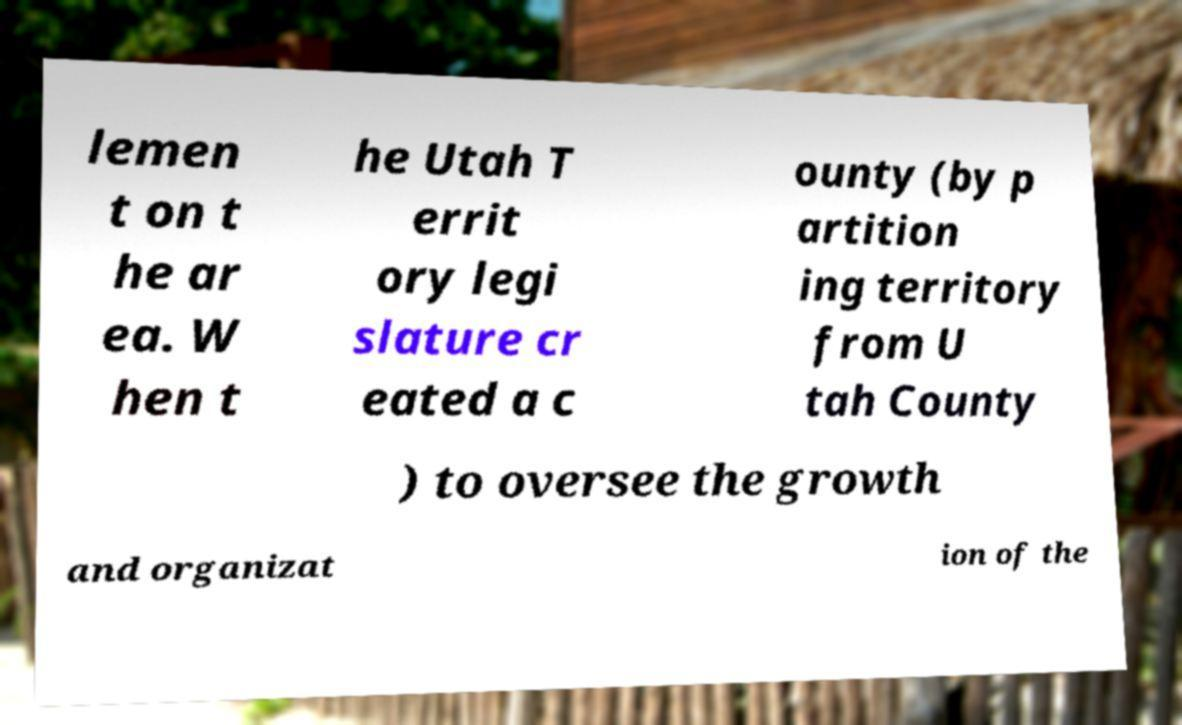Please read and relay the text visible in this image. What does it say? lemen t on t he ar ea. W hen t he Utah T errit ory legi slature cr eated a c ounty (by p artition ing territory from U tah County ) to oversee the growth and organizat ion of the 